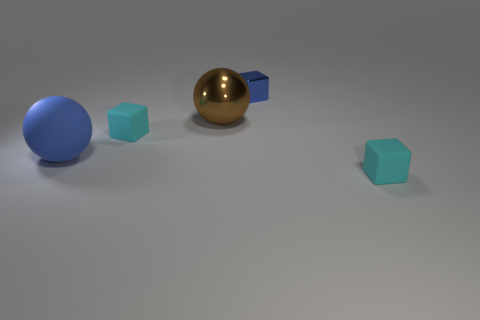Subtract all matte cubes. How many cubes are left? 1 Add 1 tiny cubes. How many objects exist? 6 Subtract all purple cylinders. How many cyan cubes are left? 2 Subtract all brown spheres. How many spheres are left? 1 Subtract 1 blocks. How many blocks are left? 2 Subtract all spheres. How many objects are left? 3 Subtract all blue cubes. Subtract all yellow cylinders. How many cubes are left? 2 Subtract all blue matte things. Subtract all big matte things. How many objects are left? 3 Add 4 brown metallic balls. How many brown metallic balls are left? 5 Add 1 yellow rubber objects. How many yellow rubber objects exist? 1 